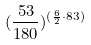<formula> <loc_0><loc_0><loc_500><loc_500>( \frac { 5 3 } { 1 8 0 } ) ^ { ( \frac { 6 } { 2 } \cdot 8 3 ) }</formula> 